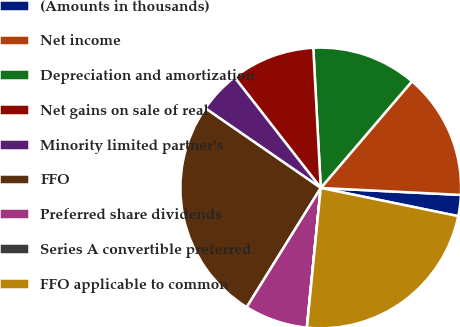<chart> <loc_0><loc_0><loc_500><loc_500><pie_chart><fcel>(Amounts in thousands)<fcel>Net income<fcel>Depreciation and amortization<fcel>Net gains on sale of real<fcel>Minority limited partner's<fcel>FFO<fcel>Preferred share dividends<fcel>Series A convertible preferred<fcel>FFO applicable to common<nl><fcel>2.43%<fcel>14.53%<fcel>12.11%<fcel>9.69%<fcel>4.85%<fcel>25.77%<fcel>7.27%<fcel>0.01%<fcel>23.35%<nl></chart> 